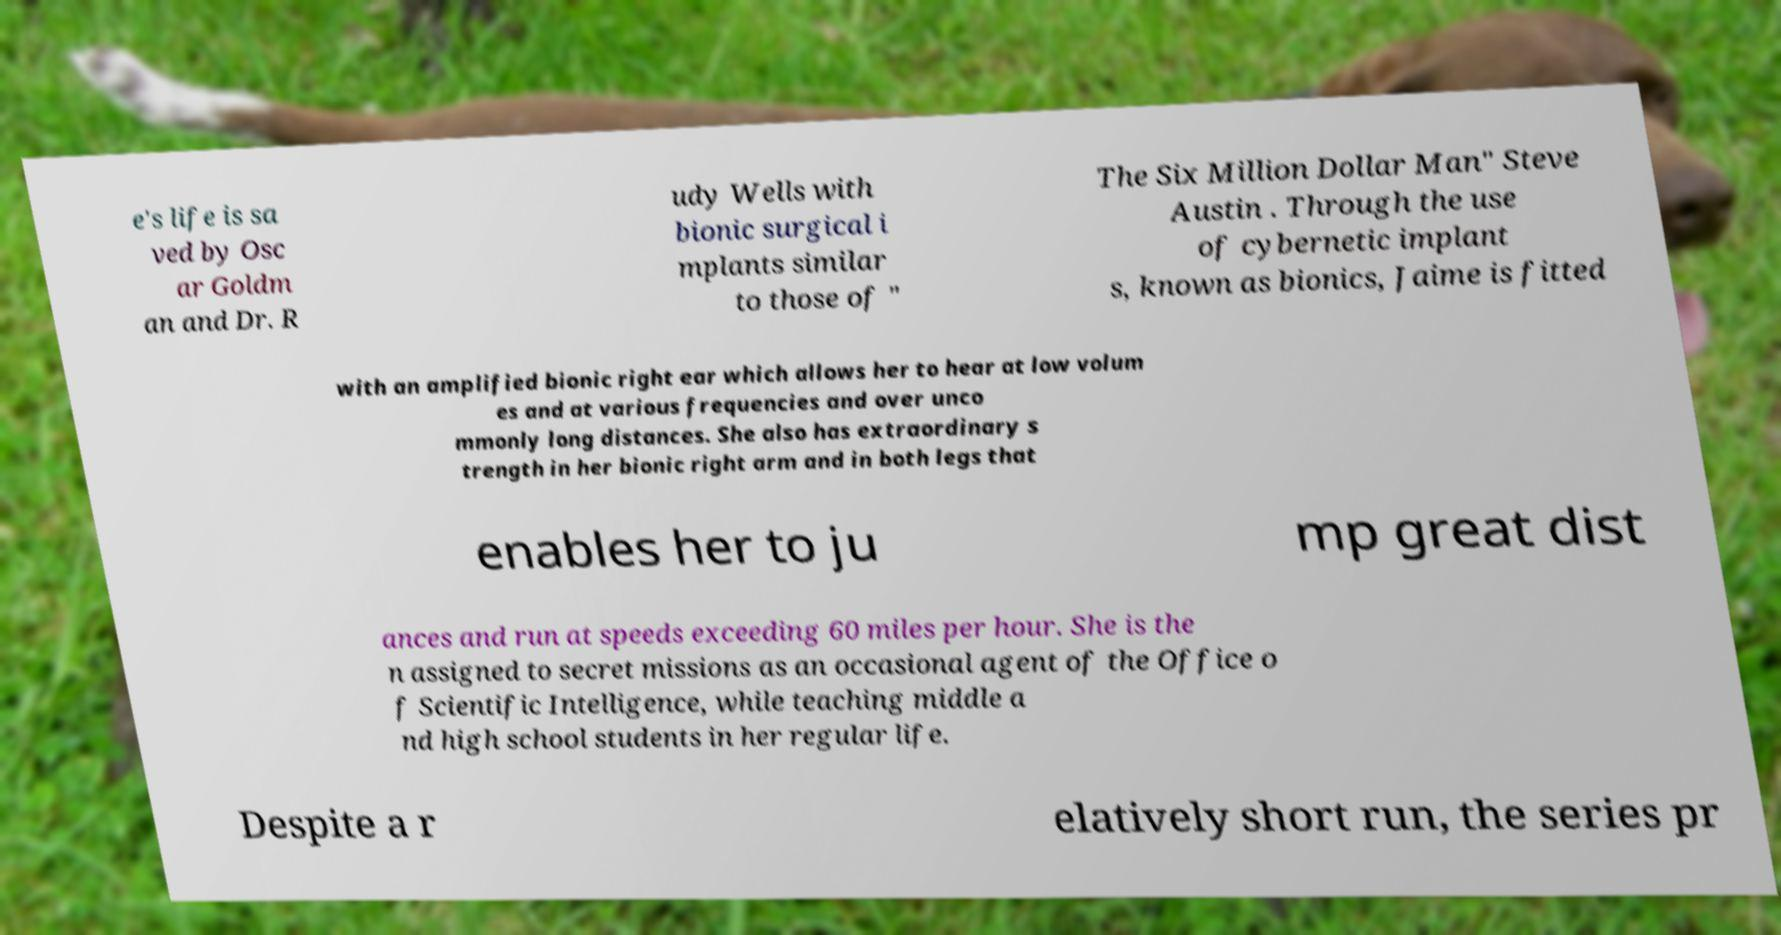I need the written content from this picture converted into text. Can you do that? e's life is sa ved by Osc ar Goldm an and Dr. R udy Wells with bionic surgical i mplants similar to those of " The Six Million Dollar Man" Steve Austin . Through the use of cybernetic implant s, known as bionics, Jaime is fitted with an amplified bionic right ear which allows her to hear at low volum es and at various frequencies and over unco mmonly long distances. She also has extraordinary s trength in her bionic right arm and in both legs that enables her to ju mp great dist ances and run at speeds exceeding 60 miles per hour. She is the n assigned to secret missions as an occasional agent of the Office o f Scientific Intelligence, while teaching middle a nd high school students in her regular life. Despite a r elatively short run, the series pr 